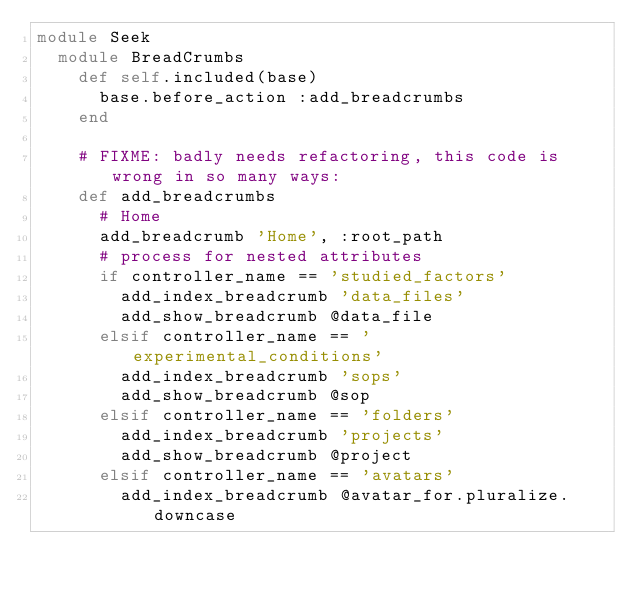Convert code to text. <code><loc_0><loc_0><loc_500><loc_500><_Ruby_>module Seek
  module BreadCrumbs
    def self.included(base)
      base.before_action :add_breadcrumbs
    end

    # FIXME: badly needs refactoring, this code is wrong in so many ways:
    def add_breadcrumbs
      # Home
      add_breadcrumb 'Home', :root_path
      # process for nested attributes
      if controller_name == 'studied_factors'
        add_index_breadcrumb 'data_files'
        add_show_breadcrumb @data_file
      elsif controller_name == 'experimental_conditions'
        add_index_breadcrumb 'sops'
        add_show_breadcrumb @sop
      elsif controller_name == 'folders'
        add_index_breadcrumb 'projects'
        add_show_breadcrumb @project
      elsif controller_name == 'avatars'
        add_index_breadcrumb @avatar_for.pluralize.downcase</code> 